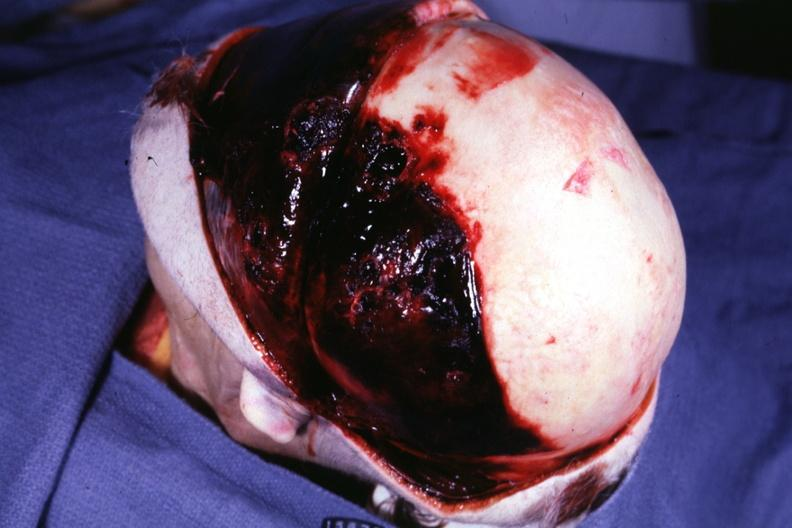does this protocol have basal skull fracture chronic subdural hematoma malignant lymphoma and acute myelogenous leukemia?
Answer the question using a single word or phrase. Yes 